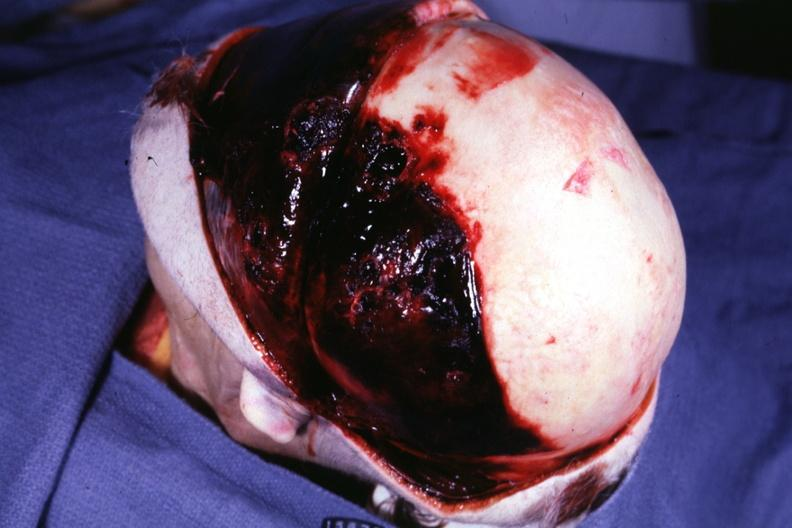does this protocol have basal skull fracture chronic subdural hematoma malignant lymphoma and acute myelogenous leukemia?
Answer the question using a single word or phrase. Yes 